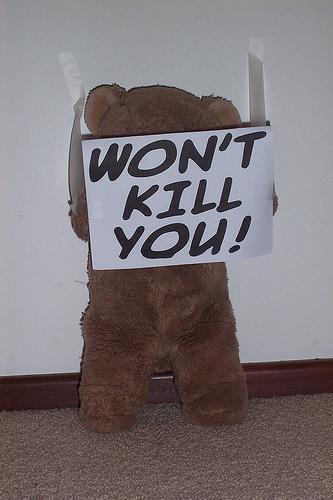How many of the bears ears are showing?
Give a very brief answer. 2. 